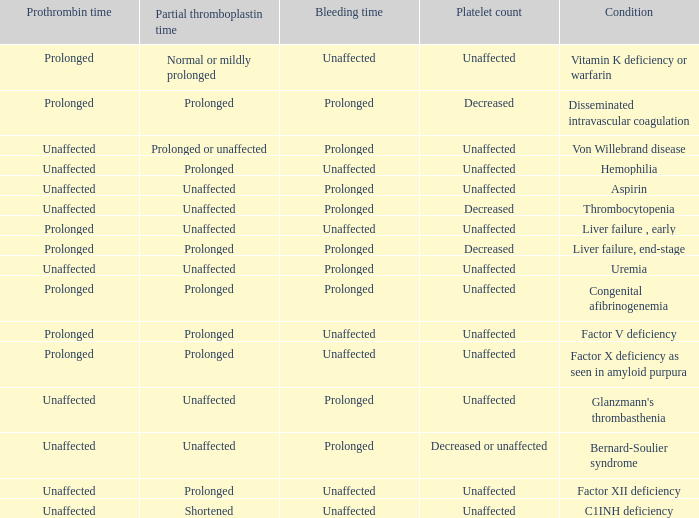In which scenario does the prothrombin time have an unaffected platelet count, unaffected bleeding time, and a normal or mildly prolonged partial thromboplastin time? Prolonged. Parse the full table. {'header': ['Prothrombin time', 'Partial thromboplastin time', 'Bleeding time', 'Platelet count', 'Condition'], 'rows': [['Prolonged', 'Normal or mildly prolonged', 'Unaffected', 'Unaffected', 'Vitamin K deficiency or warfarin'], ['Prolonged', 'Prolonged', 'Prolonged', 'Decreased', 'Disseminated intravascular coagulation'], ['Unaffected', 'Prolonged or unaffected', 'Prolonged', 'Unaffected', 'Von Willebrand disease'], ['Unaffected', 'Prolonged', 'Unaffected', 'Unaffected', 'Hemophilia'], ['Unaffected', 'Unaffected', 'Prolonged', 'Unaffected', 'Aspirin'], ['Unaffected', 'Unaffected', 'Prolonged', 'Decreased', 'Thrombocytopenia'], ['Prolonged', 'Unaffected', 'Unaffected', 'Unaffected', 'Liver failure , early'], ['Prolonged', 'Prolonged', 'Prolonged', 'Decreased', 'Liver failure, end-stage'], ['Unaffected', 'Unaffected', 'Prolonged', 'Unaffected', 'Uremia'], ['Prolonged', 'Prolonged', 'Prolonged', 'Unaffected', 'Congenital afibrinogenemia'], ['Prolonged', 'Prolonged', 'Unaffected', 'Unaffected', 'Factor V deficiency'], ['Prolonged', 'Prolonged', 'Unaffected', 'Unaffected', 'Factor X deficiency as seen in amyloid purpura'], ['Unaffected', 'Unaffected', 'Prolonged', 'Unaffected', "Glanzmann's thrombasthenia"], ['Unaffected', 'Unaffected', 'Prolonged', 'Decreased or unaffected', 'Bernard-Soulier syndrome'], ['Unaffected', 'Prolonged', 'Unaffected', 'Unaffected', 'Factor XII deficiency'], ['Unaffected', 'Shortened', 'Unaffected', 'Unaffected', 'C1INH deficiency']]} 